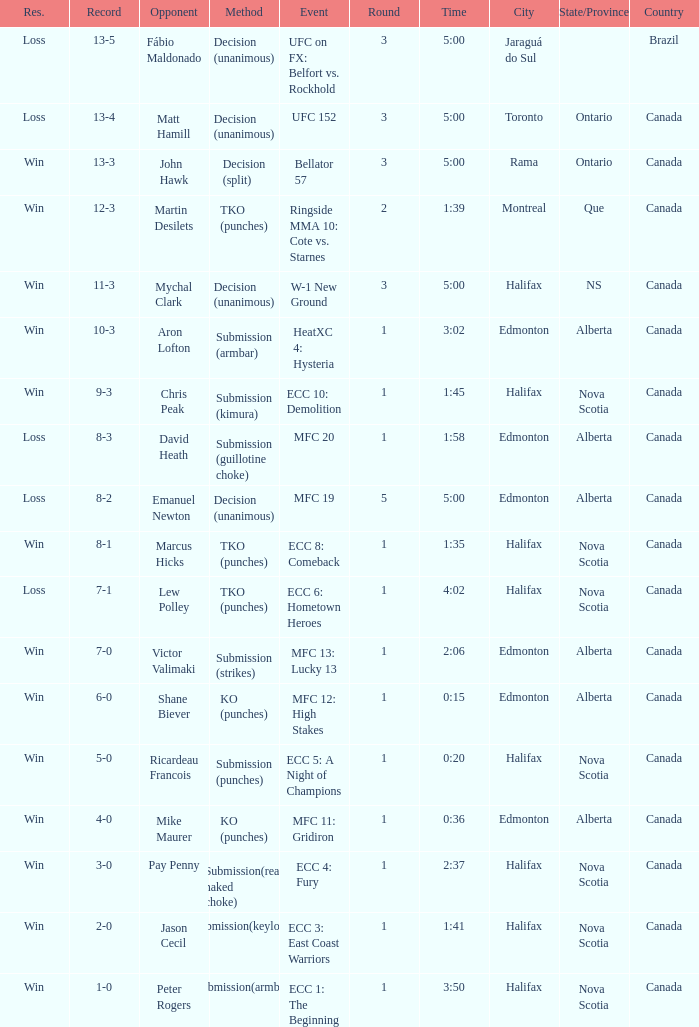What is the technique for the game with 1 round and a time of 1:58? Submission (guillotine choke). 